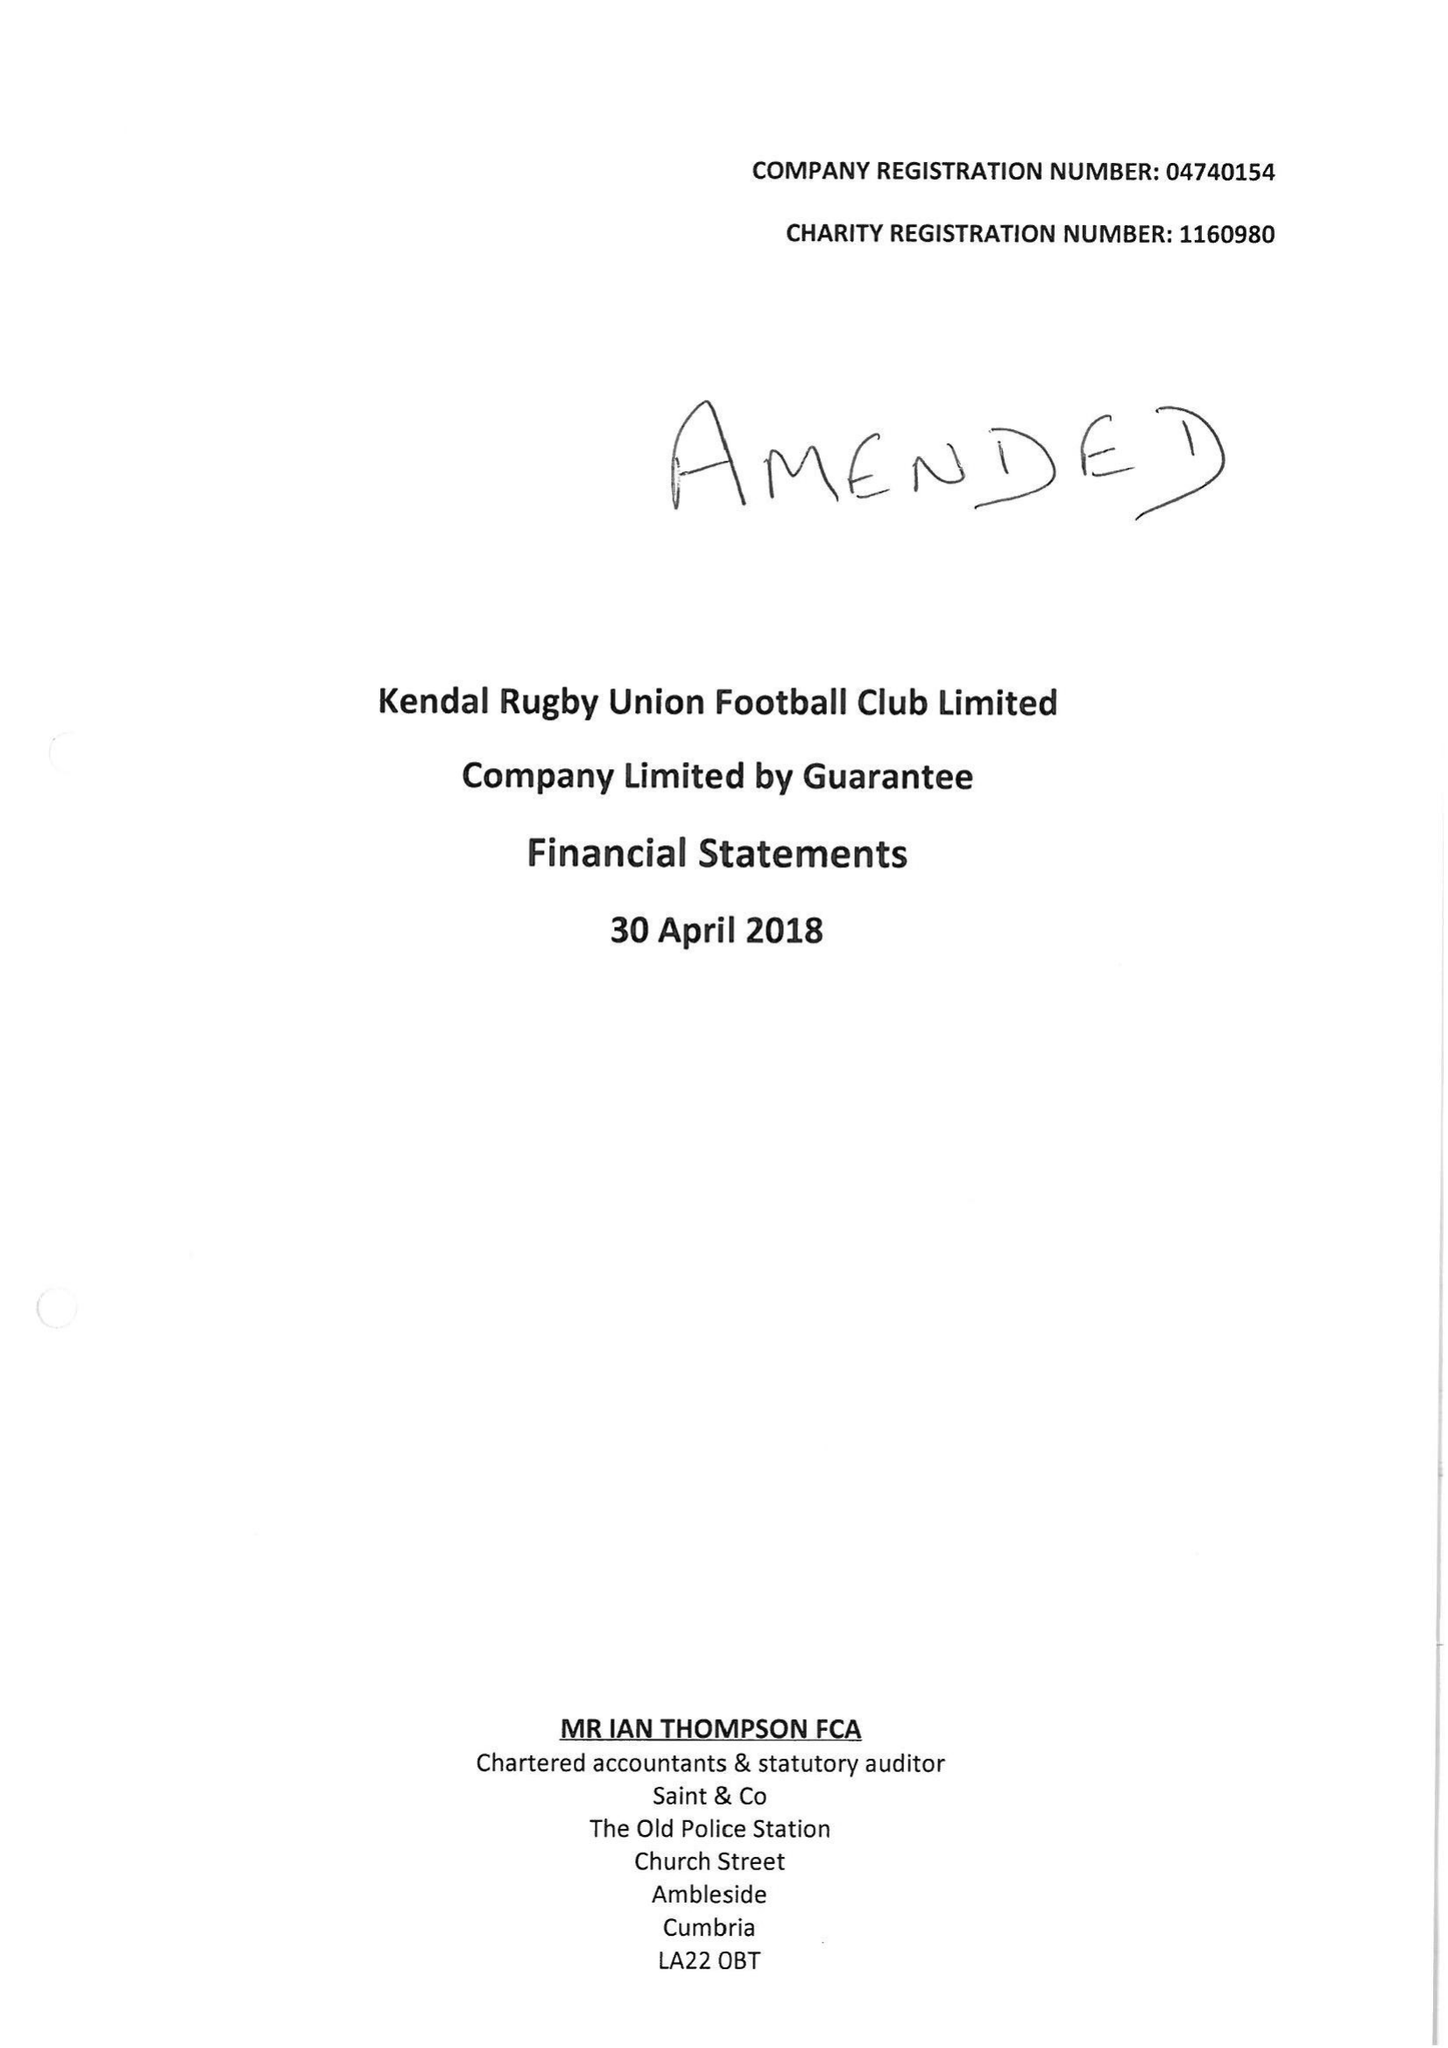What is the value for the address__post_town?
Answer the question using a single word or phrase. KENDAL 